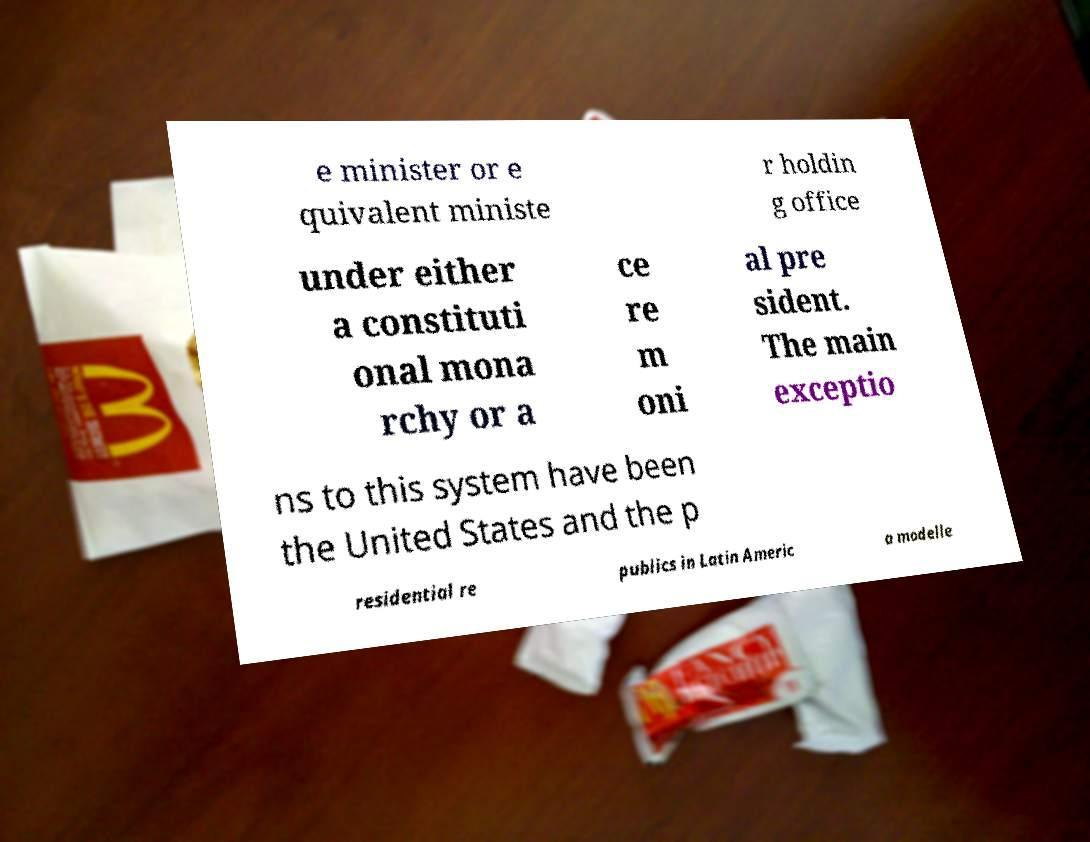Please read and relay the text visible in this image. What does it say? e minister or e quivalent ministe r holdin g office under either a constituti onal mona rchy or a ce re m oni al pre sident. The main exceptio ns to this system have been the United States and the p residential re publics in Latin Americ a modelle 